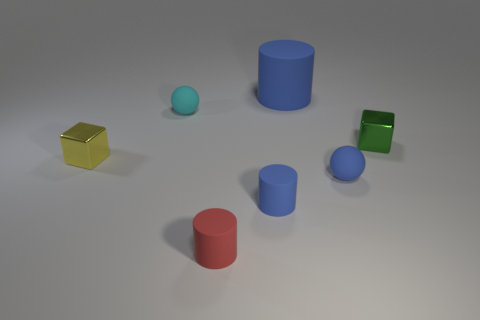Add 1 big blue matte cylinders. How many objects exist? 8 Subtract all cylinders. How many objects are left? 4 Add 7 large gray cylinders. How many large gray cylinders exist? 7 Subtract 1 red cylinders. How many objects are left? 6 Subtract all small red metal cubes. Subtract all big cylinders. How many objects are left? 6 Add 5 tiny yellow cubes. How many tiny yellow cubes are left? 6 